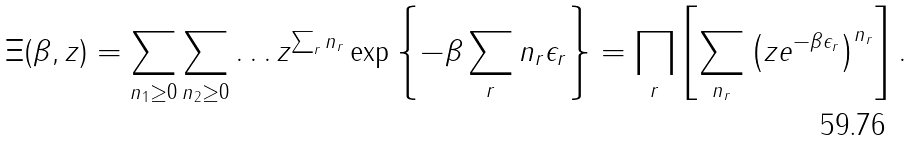<formula> <loc_0><loc_0><loc_500><loc_500>\Xi ( \beta , z ) = \sum _ { n _ { 1 } \geq 0 } \sum _ { n _ { 2 } \geq 0 } \dots z ^ { \sum _ { r } n _ { r } } \exp \left \{ - \beta \sum _ { r } n _ { r } \epsilon _ { r } \right \} = \prod _ { r } \left [ \sum _ { n _ { r } } \left ( z e ^ { - \beta \epsilon _ { r } } \right ) ^ { n _ { r } } \right ] .</formula> 